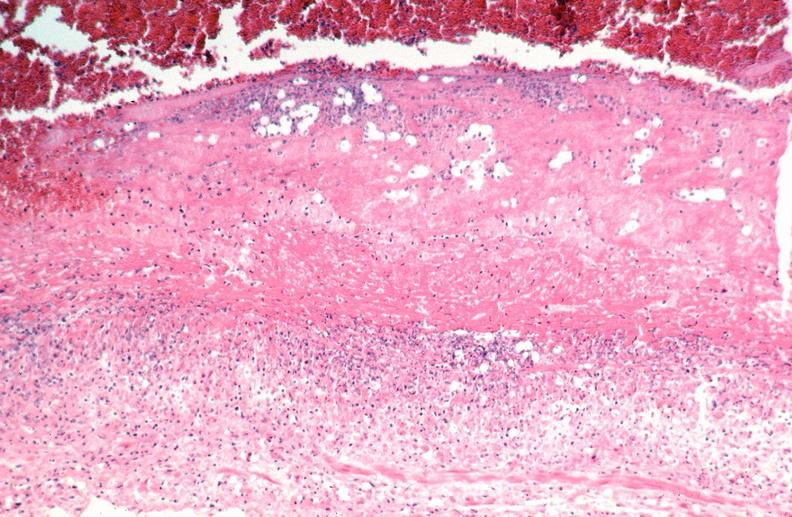s cardiovascular present?
Answer the question using a single word or phrase. Yes 